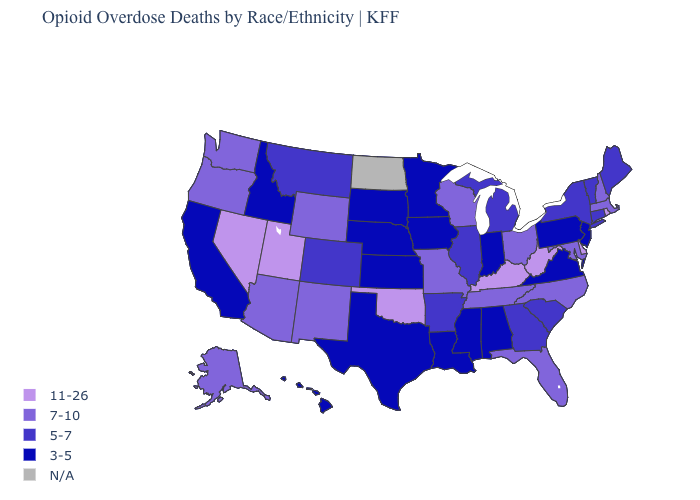Among the states that border Tennessee , which have the highest value?
Write a very short answer. Kentucky. Which states have the lowest value in the USA?
Keep it brief. Alabama, California, Hawaii, Idaho, Indiana, Iowa, Kansas, Louisiana, Minnesota, Mississippi, Nebraska, New Jersey, Pennsylvania, South Dakota, Texas, Virginia. What is the value of Illinois?
Be succinct. 5-7. Name the states that have a value in the range 3-5?
Answer briefly. Alabama, California, Hawaii, Idaho, Indiana, Iowa, Kansas, Louisiana, Minnesota, Mississippi, Nebraska, New Jersey, Pennsylvania, South Dakota, Texas, Virginia. Which states hav the highest value in the MidWest?
Answer briefly. Missouri, Ohio, Wisconsin. What is the value of Massachusetts?
Write a very short answer. 7-10. Among the states that border New York , does Pennsylvania have the lowest value?
Keep it brief. Yes. Which states have the lowest value in the USA?
Give a very brief answer. Alabama, California, Hawaii, Idaho, Indiana, Iowa, Kansas, Louisiana, Minnesota, Mississippi, Nebraska, New Jersey, Pennsylvania, South Dakota, Texas, Virginia. Name the states that have a value in the range 5-7?
Be succinct. Arkansas, Colorado, Connecticut, Georgia, Illinois, Maine, Michigan, Montana, New York, South Carolina, Vermont. Name the states that have a value in the range 7-10?
Quick response, please. Alaska, Arizona, Florida, Maryland, Massachusetts, Missouri, New Hampshire, New Mexico, North Carolina, Ohio, Oregon, Tennessee, Washington, Wisconsin, Wyoming. What is the value of New Mexico?
Answer briefly. 7-10. Name the states that have a value in the range 7-10?
Quick response, please. Alaska, Arizona, Florida, Maryland, Massachusetts, Missouri, New Hampshire, New Mexico, North Carolina, Ohio, Oregon, Tennessee, Washington, Wisconsin, Wyoming. What is the value of Florida?
Short answer required. 7-10. 